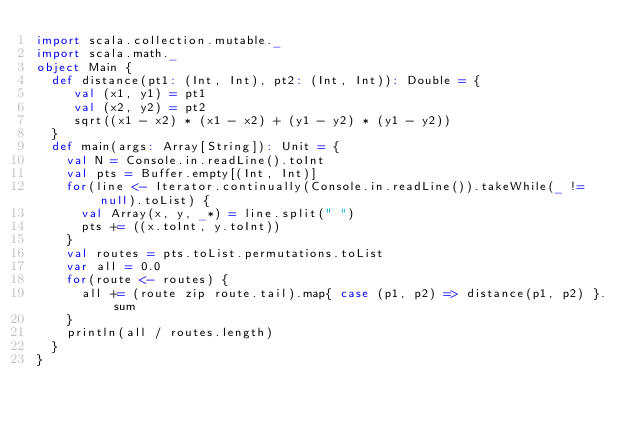Convert code to text. <code><loc_0><loc_0><loc_500><loc_500><_Scala_>import scala.collection.mutable._
import scala.math._
object Main {
  def distance(pt1: (Int, Int), pt2: (Int, Int)): Double = {
     val (x1, y1) = pt1
     val (x2, y2) = pt2
     sqrt((x1 - x2) * (x1 - x2) + (y1 - y2) * (y1 - y2))
  }
  def main(args: Array[String]): Unit = {
    val N = Console.in.readLine().toInt
    val pts = Buffer.empty[(Int, Int)]
    for(line <- Iterator.continually(Console.in.readLine()).takeWhile(_ != null).toList) {
      val Array(x, y, _*) = line.split(" ")
      pts += ((x.toInt, y.toInt))
    }
    val routes = pts.toList.permutations.toList
    var all = 0.0
    for(route <- routes) {
      all += (route zip route.tail).map{ case (p1, p2) => distance(p1, p2) }.sum
    }
    println(all / routes.length)
  }
}</code> 